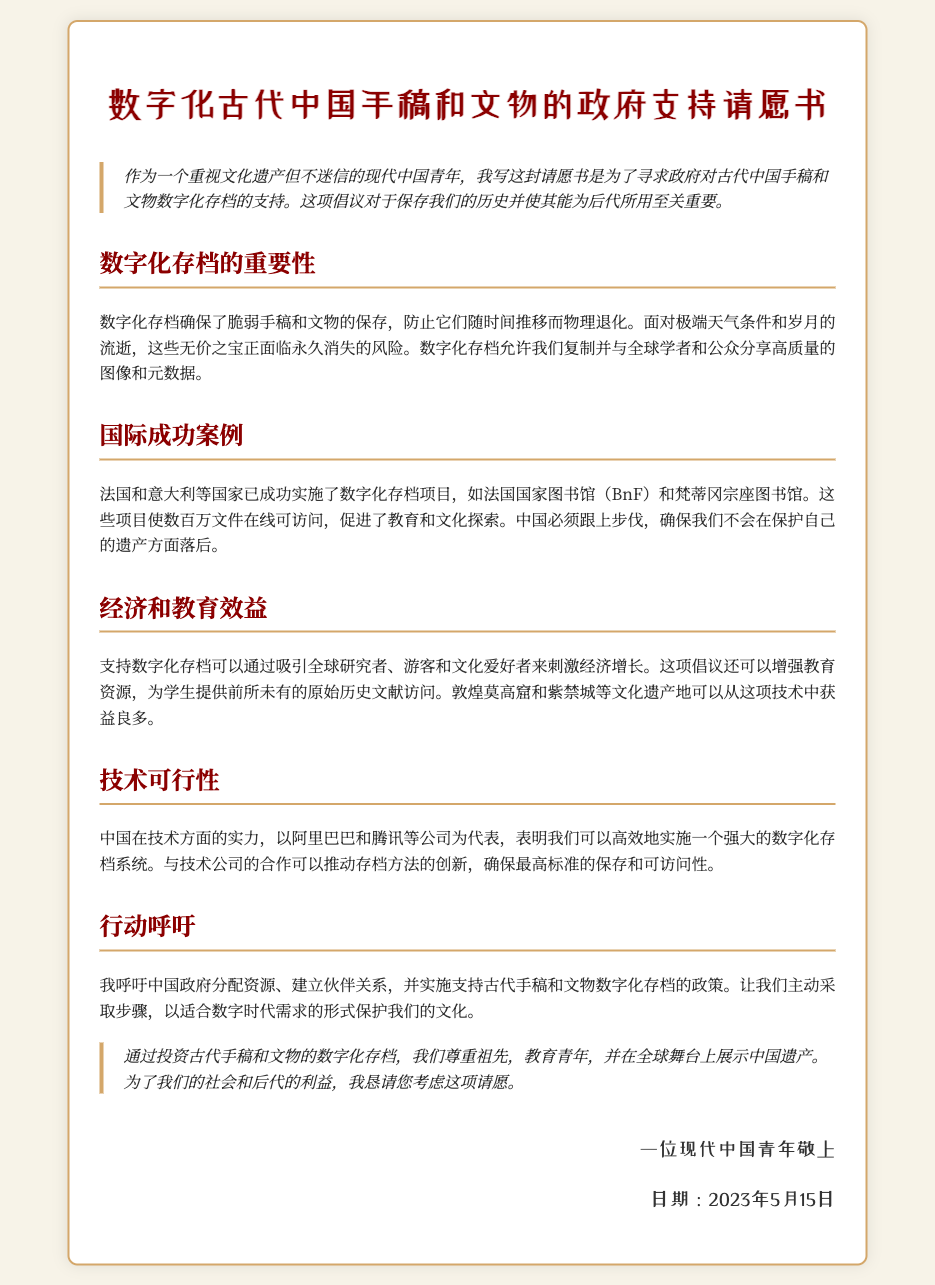What is the title of the petition? The title is clearly indicated at the beginning of the document.
Answer: 数字化古代中国手稿和文物的政府支持请愿书 What date was the petition signed? The date is mentioned at the end of the document in the signature section.
Answer: 2023年5月15日 What is one successful international example of digital archiving mentioned? The document lists successful international projects as examples in support of the argument.
Answer: 法国国家图书馆（BnF） Which technology companies are mentioned as leaders in China? The document highlights specific companies as examples of technological strength in China.
Answer: 阿里巴巴和腾讯 What is the main call to action in the petition? The document articulates the main request towards the end of the text.
Answer: 分配资源、建立伙伴关系 How does digital archiving benefit education? The text explains the potential educational enhancements due to digital archiving.
Answer: 提供前所未有的原始历史文献访问 What cultural heritage sites are specifically mentioned as beneficiaries? The document points out specific sites that could gain from this initiative.
Answer: 敦煌莫高窟和紫禁城 What is the overall goal of the petition? The overriding intention of the petition is outlined in the introduction and conclusion.
Answer: 对古代中国手稿和文物数字化存档的支持 